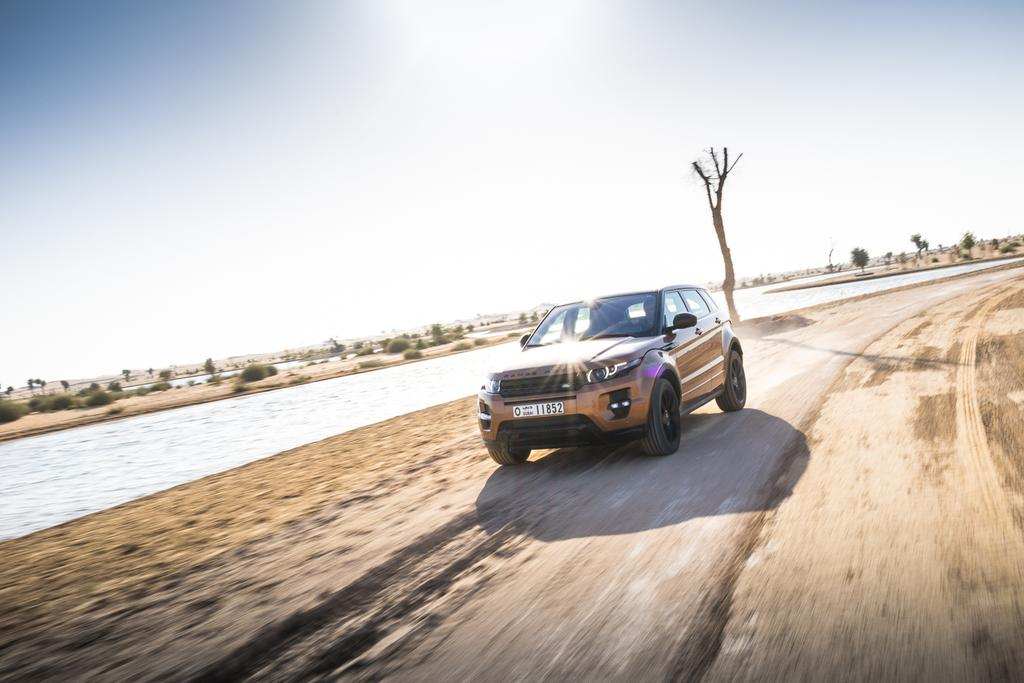What is located on the path in the image? There is a car on the path in the image. What natural element can be seen in the image? Water is visible in the image. What type of vegetation is in the background of the image? There are bushes and trees in the background of the image. What is visible at the top of the image? The sky is visible at the top of the image. What type of bell can be heard ringing in the image? There is no bell present in the image, and therefore no sound can be heard. How many accounts are visible in the image? There are no accounts visible in the image. 